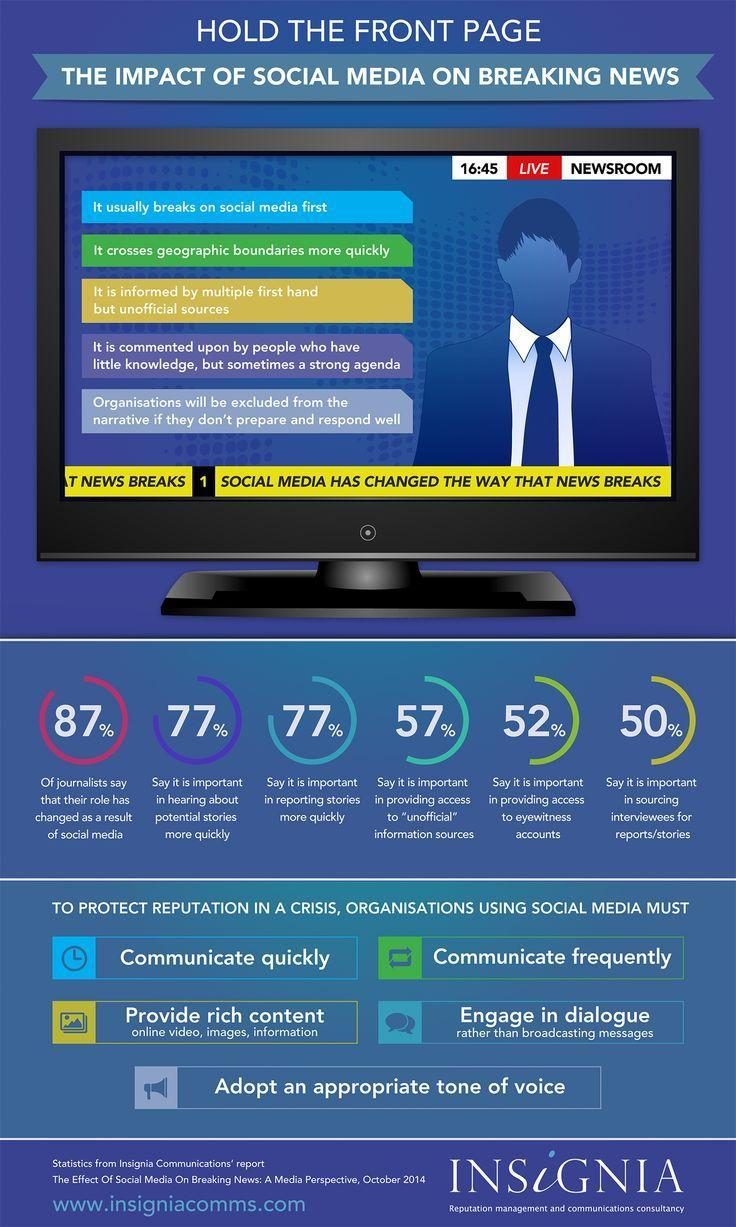What percentage of journalists say that social media  is important in providing access to eyewitness accounts?
Answer the question with a short phrase. 52% What percentage of journalists say that their role has changed as a result of social media? 87% What percentage of journalists say that social media is important in reporting stories more quickly? 77% 